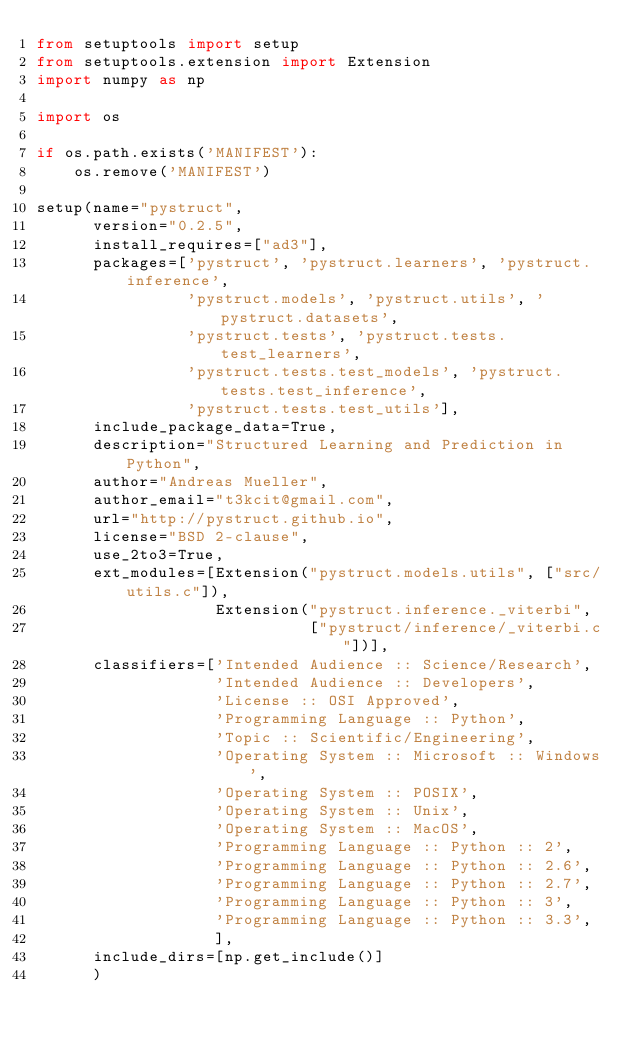Convert code to text. <code><loc_0><loc_0><loc_500><loc_500><_Python_>from setuptools import setup
from setuptools.extension import Extension
import numpy as np

import os

if os.path.exists('MANIFEST'):
    os.remove('MANIFEST')

setup(name="pystruct",
      version="0.2.5",
      install_requires=["ad3"],
      packages=['pystruct', 'pystruct.learners', 'pystruct.inference',
                'pystruct.models', 'pystruct.utils', 'pystruct.datasets',
                'pystruct.tests', 'pystruct.tests.test_learners',
                'pystruct.tests.test_models', 'pystruct.tests.test_inference',
                'pystruct.tests.test_utils'],
      include_package_data=True,
      description="Structured Learning and Prediction in Python",
      author="Andreas Mueller",
      author_email="t3kcit@gmail.com",
      url="http://pystruct.github.io",
      license="BSD 2-clause",
      use_2to3=True,
      ext_modules=[Extension("pystruct.models.utils", ["src/utils.c"]),
                   Extension("pystruct.inference._viterbi",
                             ["pystruct/inference/_viterbi.c"])],
      classifiers=['Intended Audience :: Science/Research',
                   'Intended Audience :: Developers',
                   'License :: OSI Approved',
                   'Programming Language :: Python',
                   'Topic :: Scientific/Engineering',
                   'Operating System :: Microsoft :: Windows',
                   'Operating System :: POSIX',
                   'Operating System :: Unix',
                   'Operating System :: MacOS',
                   'Programming Language :: Python :: 2',
                   'Programming Language :: Python :: 2.6',
                   'Programming Language :: Python :: 2.7',
                   'Programming Language :: Python :: 3',
                   'Programming Language :: Python :: 3.3',
                   ],
      include_dirs=[np.get_include()]
      )
</code> 